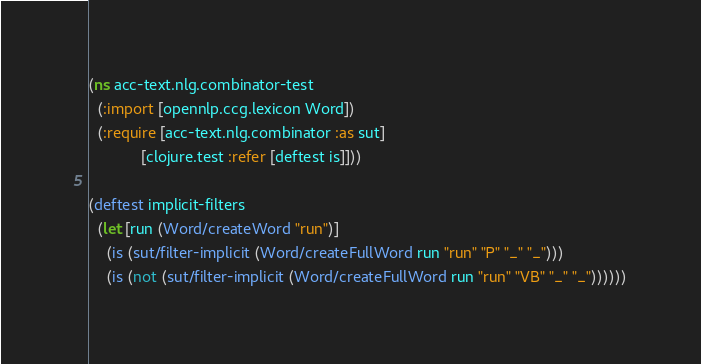Convert code to text. <code><loc_0><loc_0><loc_500><loc_500><_Clojure_>(ns acc-text.nlg.combinator-test
  (:import [opennlp.ccg.lexicon Word])
  (:require [acc-text.nlg.combinator :as sut]
            [clojure.test :refer [deftest is]]))

(deftest implicit-filters
  (let [run (Word/createWord "run")]
    (is (sut/filter-implicit (Word/createFullWord run "run" "P" "_" "_")))
    (is (not (sut/filter-implicit (Word/createFullWord run "run" "VB" "_" "_"))))))
</code> 